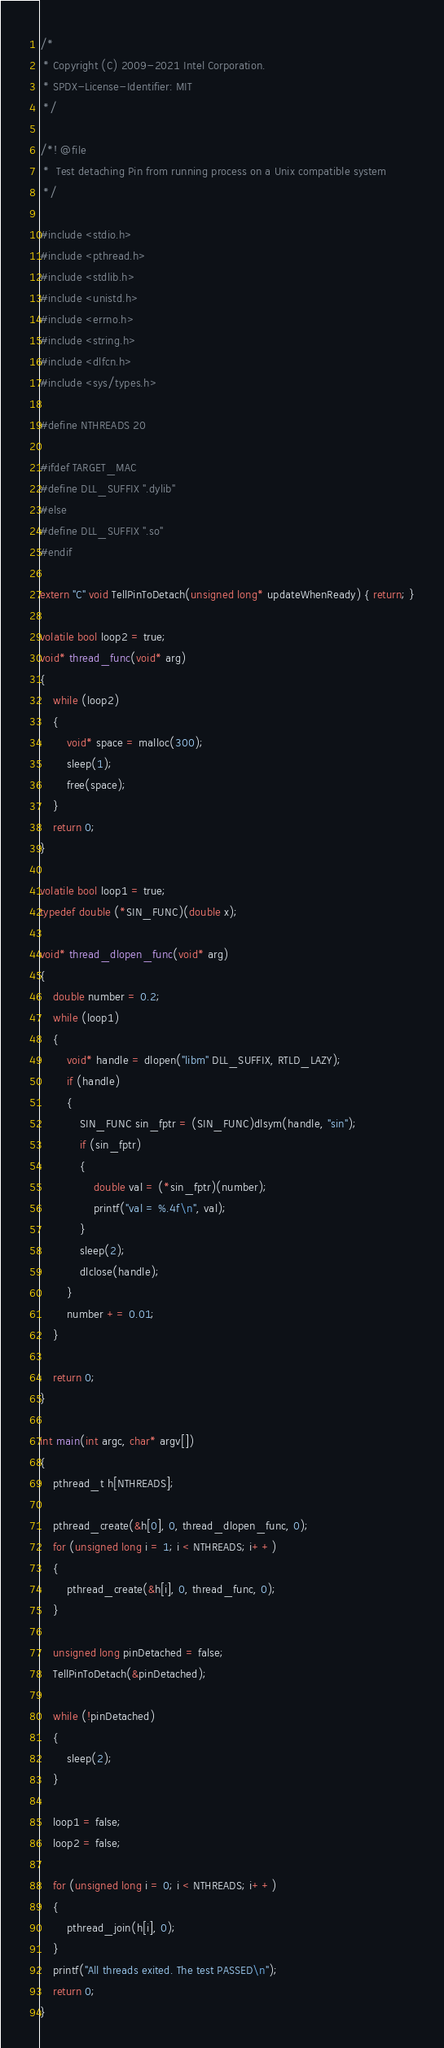<code> <loc_0><loc_0><loc_500><loc_500><_C++_>/*
 * Copyright (C) 2009-2021 Intel Corporation.
 * SPDX-License-Identifier: MIT
 */

/*! @file
 *  Test detaching Pin from running process on a Unix compatible system
 */

#include <stdio.h>
#include <pthread.h>
#include <stdlib.h>
#include <unistd.h>
#include <errno.h>
#include <string.h>
#include <dlfcn.h>
#include <sys/types.h>

#define NTHREADS 20

#ifdef TARGET_MAC
#define DLL_SUFFIX ".dylib"
#else
#define DLL_SUFFIX ".so"
#endif

extern "C" void TellPinToDetach(unsigned long* updateWhenReady) { return; }

volatile bool loop2 = true;
void* thread_func(void* arg)
{
    while (loop2)
    {
        void* space = malloc(300);
        sleep(1);
        free(space);
    }
    return 0;
}

volatile bool loop1 = true;
typedef double (*SIN_FUNC)(double x);

void* thread_dlopen_func(void* arg)
{
    double number = 0.2;
    while (loop1)
    {
        void* handle = dlopen("libm" DLL_SUFFIX, RTLD_LAZY);
        if (handle)
        {
            SIN_FUNC sin_fptr = (SIN_FUNC)dlsym(handle, "sin");
            if (sin_fptr)
            {
                double val = (*sin_fptr)(number);
                printf("val = %.4f\n", val);
            }
            sleep(2);
            dlclose(handle);
        }
        number += 0.01;
    }

    return 0;
}

int main(int argc, char* argv[])
{
    pthread_t h[NTHREADS];

    pthread_create(&h[0], 0, thread_dlopen_func, 0);
    for (unsigned long i = 1; i < NTHREADS; i++)
    {
        pthread_create(&h[i], 0, thread_func, 0);
    }

    unsigned long pinDetached = false;
    TellPinToDetach(&pinDetached);

    while (!pinDetached)
    {
        sleep(2);
    }

    loop1 = false;
    loop2 = false;

    for (unsigned long i = 0; i < NTHREADS; i++)
    {
        pthread_join(h[i], 0);
    }
    printf("All threads exited. The test PASSED\n");
    return 0;
}
</code> 